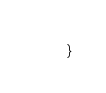<code> <loc_0><loc_0><loc_500><loc_500><_Java_>}
</code> 